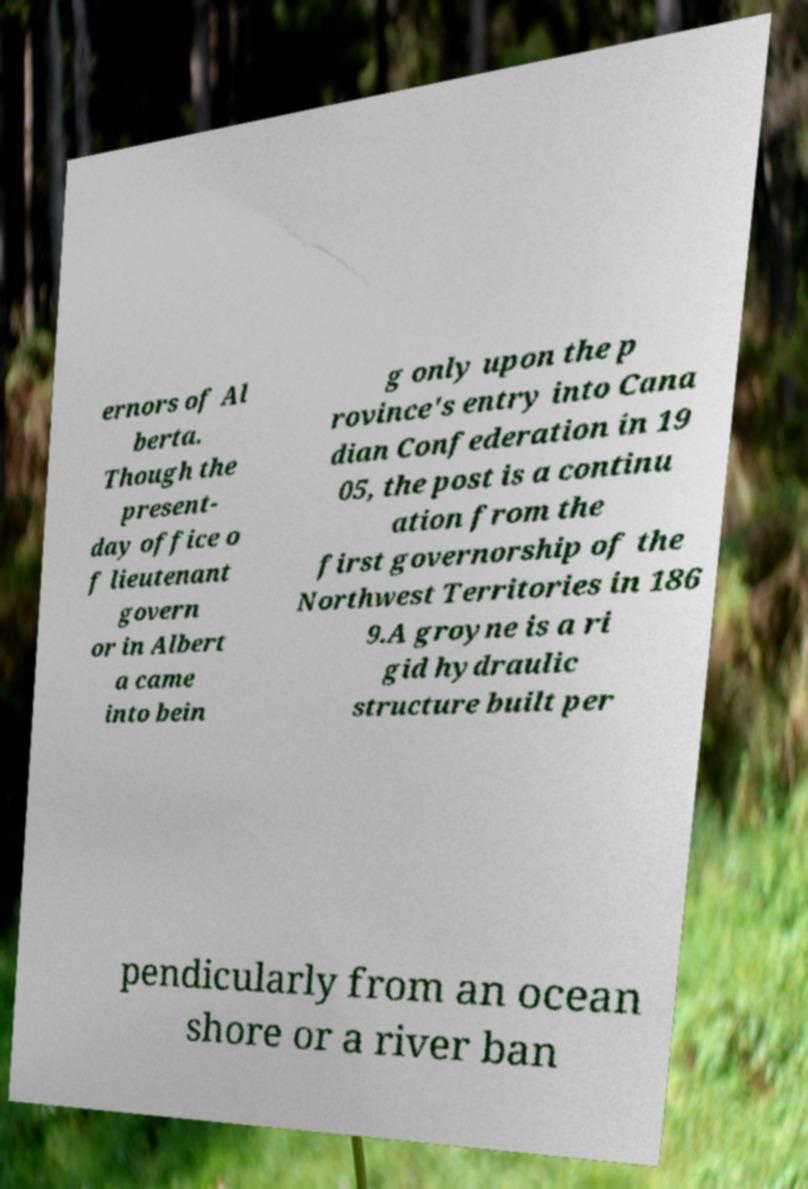Please read and relay the text visible in this image. What does it say? ernors of Al berta. Though the present- day office o f lieutenant govern or in Albert a came into bein g only upon the p rovince's entry into Cana dian Confederation in 19 05, the post is a continu ation from the first governorship of the Northwest Territories in 186 9.A groyne is a ri gid hydraulic structure built per pendicularly from an ocean shore or a river ban 